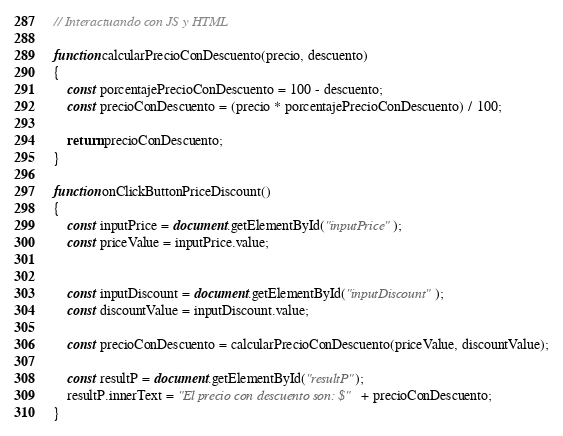Convert code to text. <code><loc_0><loc_0><loc_500><loc_500><_JavaScript_>// Interactuando con JS y HTML

function calcularPrecioConDescuento(precio, descuento)
{
    const porcentajePrecioConDescuento = 100 - descuento;
    const precioConDescuento = (precio * porcentajePrecioConDescuento) / 100;

    return precioConDescuento;
}

function onClickButtonPriceDiscount()
{
    const inputPrice = document.getElementById("inputPrice");
    const priceValue = inputPrice.value;


    const inputDiscount = document.getElementById("inputDiscount");
    const discountValue = inputDiscount.value;

    const precioConDescuento = calcularPrecioConDescuento(priceValue, discountValue);
    
    const resultP = document.getElementById("resultP");
    resultP.innerText = "El precio con descuento son: $" + precioConDescuento;
}</code> 